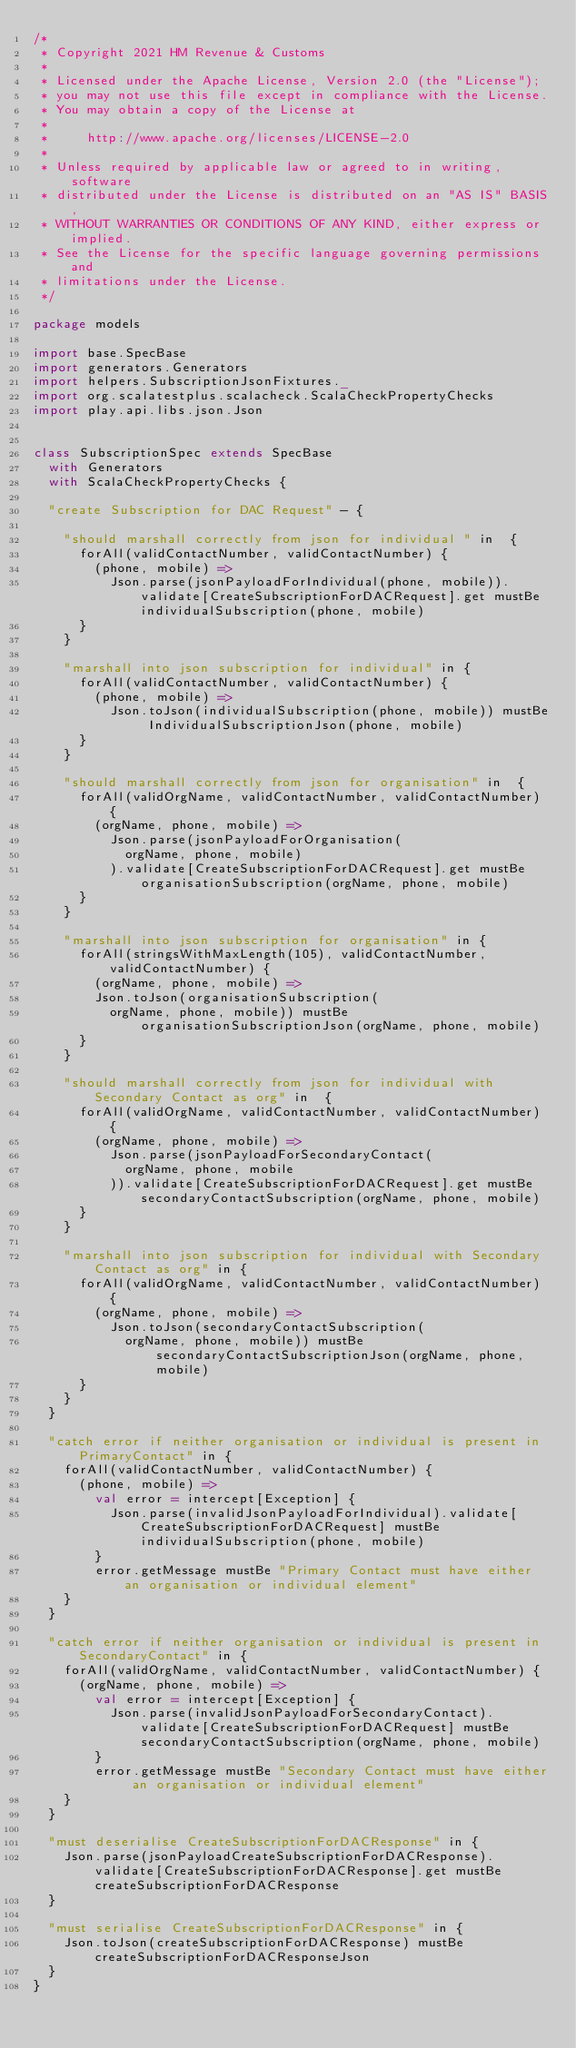<code> <loc_0><loc_0><loc_500><loc_500><_Scala_>/*
 * Copyright 2021 HM Revenue & Customs
 *
 * Licensed under the Apache License, Version 2.0 (the "License");
 * you may not use this file except in compliance with the License.
 * You may obtain a copy of the License at
 *
 *     http://www.apache.org/licenses/LICENSE-2.0
 *
 * Unless required by applicable law or agreed to in writing, software
 * distributed under the License is distributed on an "AS IS" BASIS,
 * WITHOUT WARRANTIES OR CONDITIONS OF ANY KIND, either express or implied.
 * See the License for the specific language governing permissions and
 * limitations under the License.
 */

package models

import base.SpecBase
import generators.Generators
import helpers.SubscriptionJsonFixtures._
import org.scalatestplus.scalacheck.ScalaCheckPropertyChecks
import play.api.libs.json.Json


class SubscriptionSpec extends SpecBase
  with Generators
  with ScalaCheckPropertyChecks {

  "create Subscription for DAC Request" - {

    "should marshall correctly from json for individual " in  {
      forAll(validContactNumber, validContactNumber) {
        (phone, mobile) =>
          Json.parse(jsonPayloadForIndividual(phone, mobile)).validate[CreateSubscriptionForDACRequest].get mustBe individualSubscription(phone, mobile)
      }
    }

    "marshall into json subscription for individual" in {
      forAll(validContactNumber, validContactNumber) {
        (phone, mobile) =>
          Json.toJson(individualSubscription(phone, mobile)) mustBe IndividualSubscriptionJson(phone, mobile)
      }
    }

    "should marshall correctly from json for organisation" in  {
      forAll(validOrgName, validContactNumber, validContactNumber) {
        (orgName, phone, mobile) =>
          Json.parse(jsonPayloadForOrganisation(
            orgName, phone, mobile)
          ).validate[CreateSubscriptionForDACRequest].get mustBe organisationSubscription(orgName, phone, mobile)
      }
    }

    "marshall into json subscription for organisation" in {
      forAll(stringsWithMaxLength(105), validContactNumber, validContactNumber) {
        (orgName, phone, mobile) =>
        Json.toJson(organisationSubscription(
          orgName, phone, mobile)) mustBe organisationSubscriptionJson(orgName, phone, mobile)
      }
    }

    "should marshall correctly from json for individual with Secondary Contact as org" in  {
      forAll(validOrgName, validContactNumber, validContactNumber) {
        (orgName, phone, mobile) =>
          Json.parse(jsonPayloadForSecondaryContact(
            orgName, phone, mobile
          )).validate[CreateSubscriptionForDACRequest].get mustBe secondaryContactSubscription(orgName, phone, mobile)
      }
    }

    "marshall into json subscription for individual with Secondary Contact as org" in {
      forAll(validOrgName, validContactNumber, validContactNumber) {
        (orgName, phone, mobile) =>
          Json.toJson(secondaryContactSubscription(
            orgName, phone, mobile)) mustBe secondaryContactSubscriptionJson(orgName, phone, mobile)
      }
    }
  }

  "catch error if neither organisation or individual is present in PrimaryContact" in {
    forAll(validContactNumber, validContactNumber) {
      (phone, mobile) =>
        val error = intercept[Exception] {
          Json.parse(invalidJsonPayloadForIndividual).validate[CreateSubscriptionForDACRequest] mustBe individualSubscription(phone, mobile)
        }
        error.getMessage mustBe "Primary Contact must have either an organisation or individual element"
    }
  }

  "catch error if neither organisation or individual is present in SecondaryContact" in {
    forAll(validOrgName, validContactNumber, validContactNumber) {
      (orgName, phone, mobile) =>
        val error = intercept[Exception] {
          Json.parse(invalidJsonPayloadForSecondaryContact).validate[CreateSubscriptionForDACRequest] mustBe secondaryContactSubscription(orgName, phone, mobile)
        }
        error.getMessage mustBe "Secondary Contact must have either an organisation or individual element"
    }
  }

  "must deserialise CreateSubscriptionForDACResponse" in {
    Json.parse(jsonPayloadCreateSubscriptionForDACResponse).validate[CreateSubscriptionForDACResponse].get mustBe createSubscriptionForDACResponse
  }

  "must serialise CreateSubscriptionForDACResponse" in {
    Json.toJson(createSubscriptionForDACResponse) mustBe createSubscriptionForDACResponseJson
  }
}
</code> 